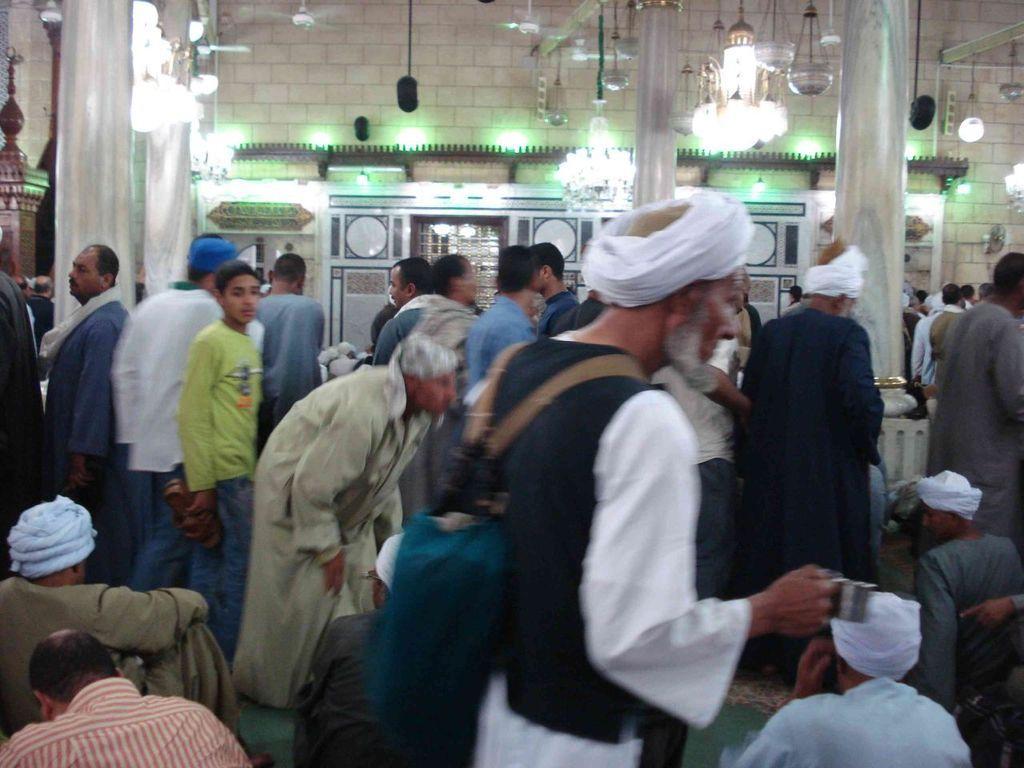Could you give a brief overview of what you see in this image? We can see group of people and we can see wall,pillars and lights. 